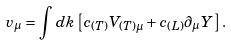<formula> <loc_0><loc_0><loc_500><loc_500>v _ { \mu } = \int d k \left [ c _ { ( T ) } V _ { ( T ) \mu } + c _ { ( L ) } \partial _ { \mu } Y \right ] .</formula> 